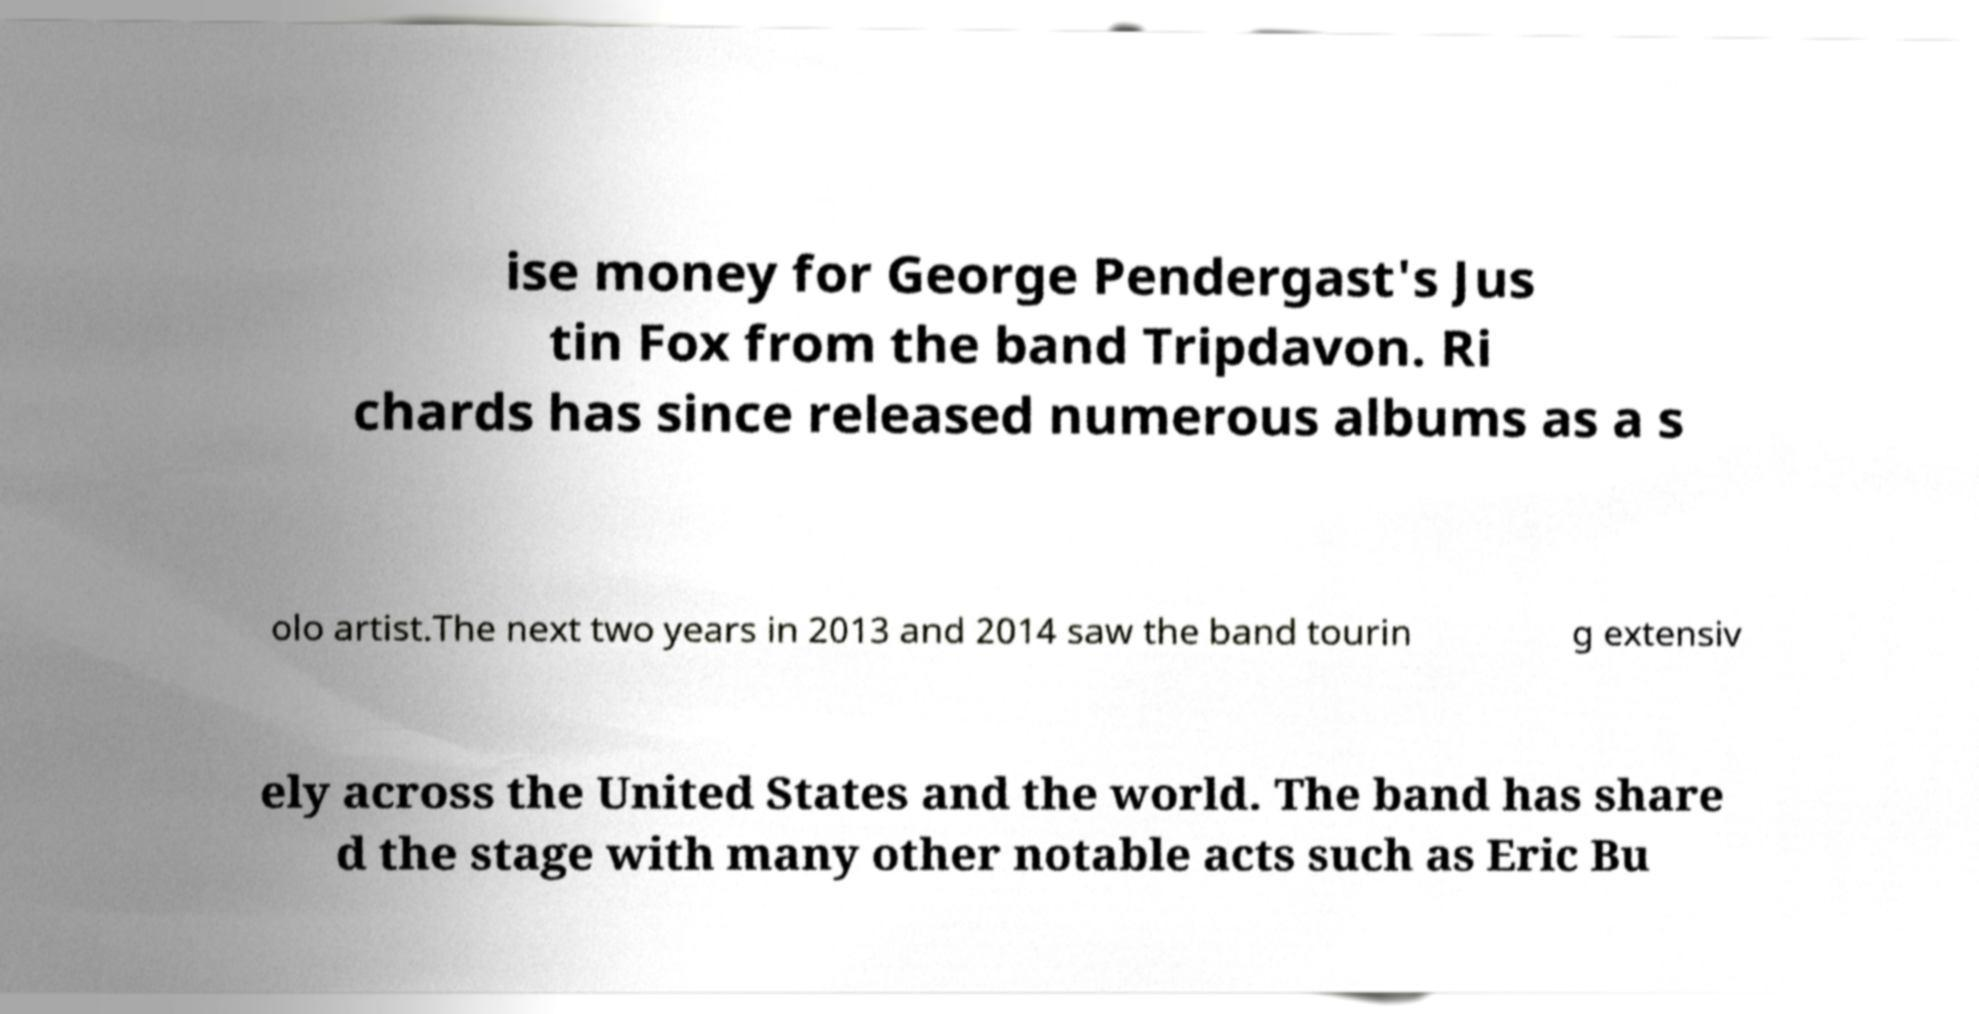Please identify and transcribe the text found in this image. ise money for George Pendergast's Jus tin Fox from the band Tripdavon. Ri chards has since released numerous albums as a s olo artist.The next two years in 2013 and 2014 saw the band tourin g extensiv ely across the United States and the world. The band has share d the stage with many other notable acts such as Eric Bu 